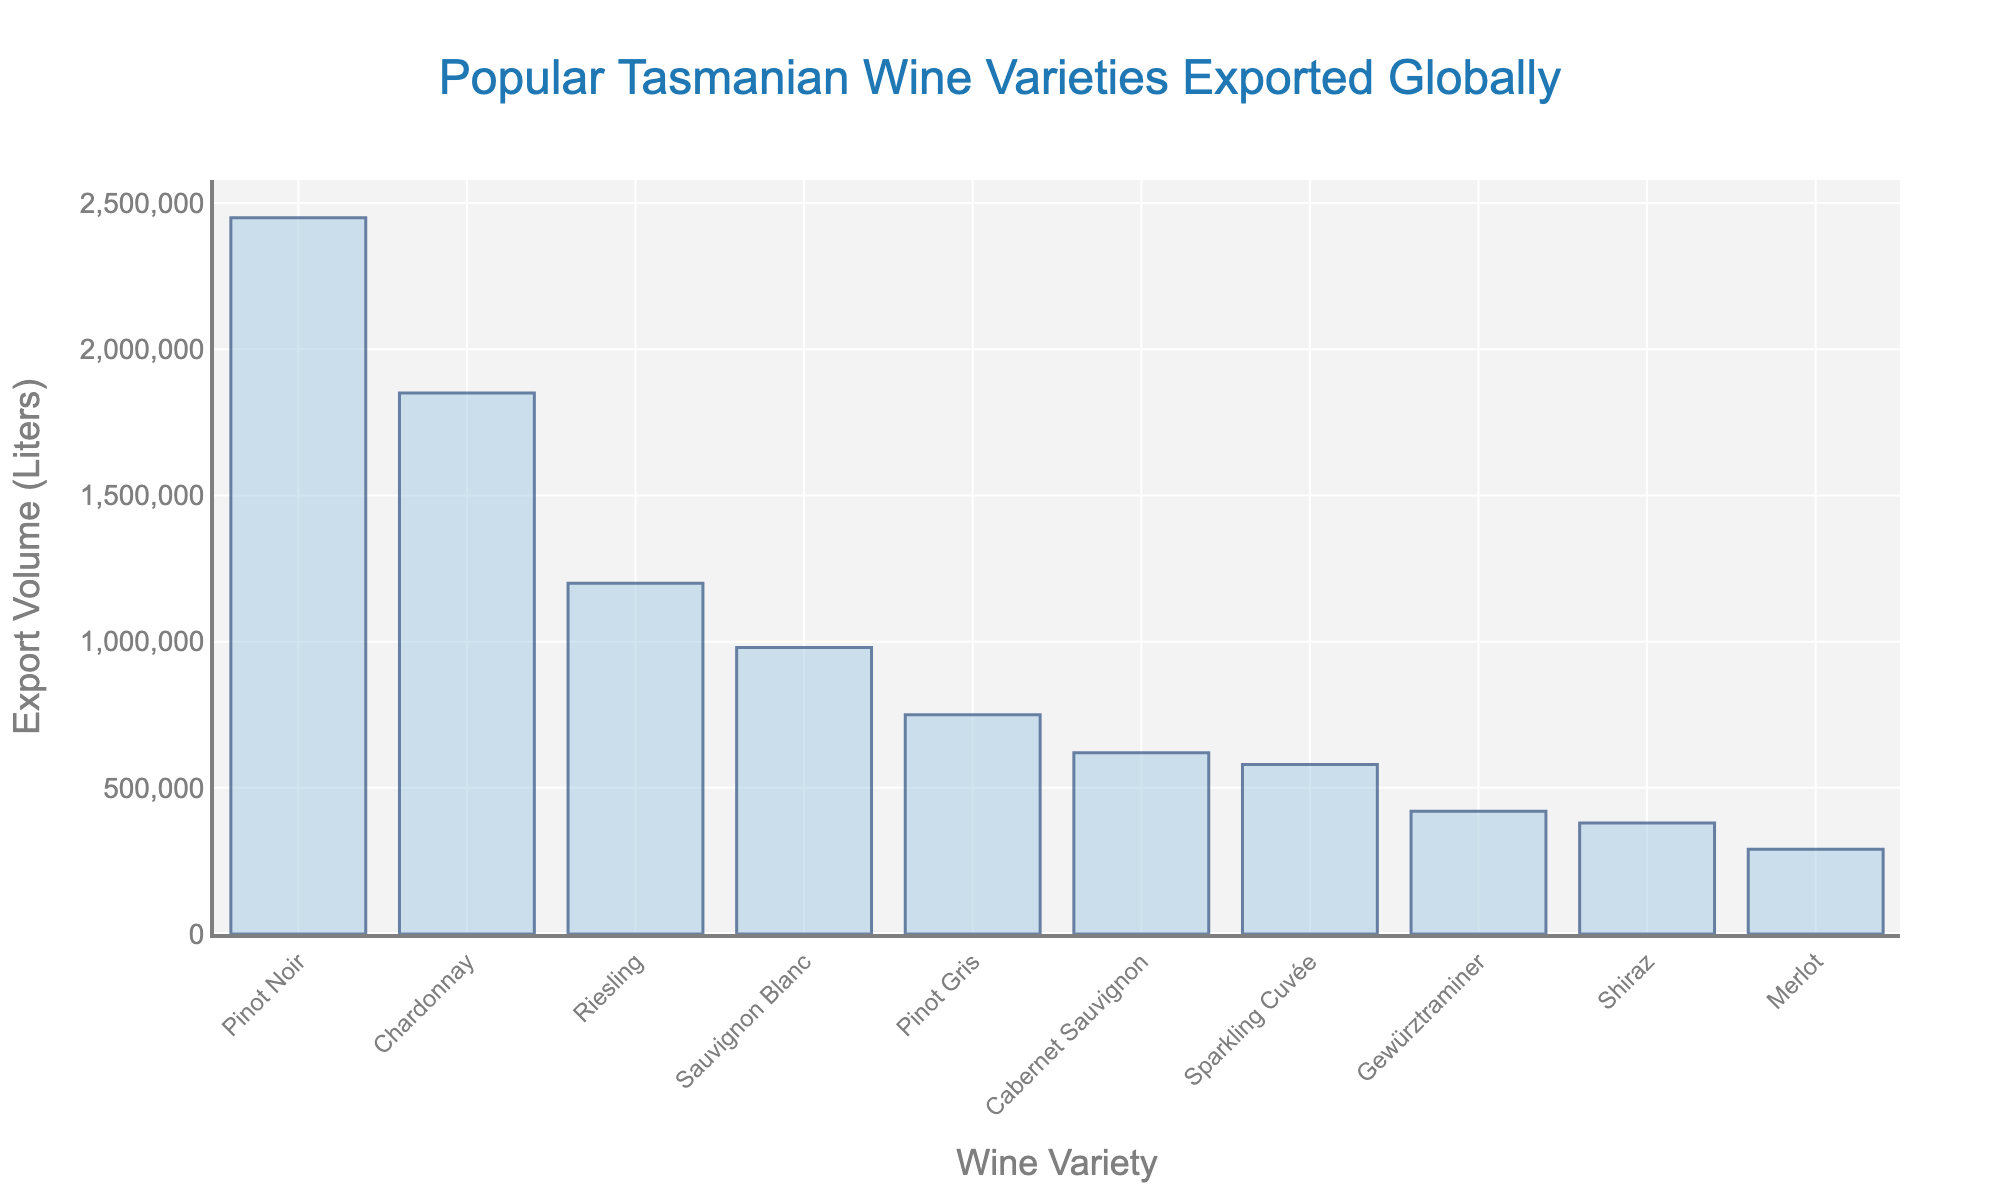Which wine variety has the highest export volume? By looking at the top of the bar chart, we can identify the tallest bar, which represents the wine variety with the highest export volume.
Answer: Pinot Noir Which wine variety has the lowest export volume? By looking at the bottom of the bar chart, we can see the shortest bar, which represents the wine variety with the lowest export volume.
Answer: Merlot How much more Pinot Noir is exported compared to Merlot? The height of the bar for Pinot Noir represents 2,450,000 liters, and the height of the bar for Merlot represents 290,000 liters. Subtracting these values gives us the difference. 2,450,000 - 290,000 = 2,160,000 liters.
Answer: 2,160,000 liters What is the combined export volume of Chardonnay and Riesling? The height of the bar for Chardonnay represents 1,850,000 liters, and the height of the bar for Riesling represents 1,200,000 liters. Adding these values gives us the combined total. 1,850,000 + 1,200,000 = 3,050,000 liters.
Answer: 3,050,000 liters Which wine variety has an export volume between 600,000 and 800,000 liters? By comparing the bar heights within the given range, we find that the bar for Pinot Gris represents 750,000 liters, which falls between 600,000 and 800,000 liters.
Answer: Pinot Gris Is the export volume of Shiraz more than half of Sauvignon Blanc's export volume? The height of the bar for Shiraz is 380,000 liters, and the height of the bar for Sauvignon Blanc is 980,000 liters. Half of 980,000 is 490,000. Since 380,000 is less than 490,000, Shiraz's export volume is not more than half of Sauvignon Blanc's.
Answer: No What is the average export volume of the top three wine varieties? The export volumes of the top three wine varieties are Pinot Noir (2,450,000 liters), Chardonnay (1,850,000 liters), and Riesling (1,200,000 liters). Summing these values and dividing by 3 gives us the average. (2,450,000 + 1,850,000 + 1,200,000) / 3 = 1,833,333.33 liters.
Answer: 1,833,333.33 liters Identify the wine variety that has an export volume closest to 1,000,000 liters. By visually comparing the bar heights to the 1,000,000 liters mark, we find that the height of the bar for Sauvignon Blanc comes closest to it, at 980,000 liters.
Answer: Sauvignon Blanc What is the total export volume for all wine varieties combined? By summing the export volumes of all the wine varieties shown in the chart, we get the total export volume. 2,450,000 + 1,850,000 + 1,200,000 + 980,000 + 750,000 + 620,000 + 580,000 + 420,000 + 380,000 + 290,000 = 9,520,000 liters.
Answer: 9,520,000 liters 